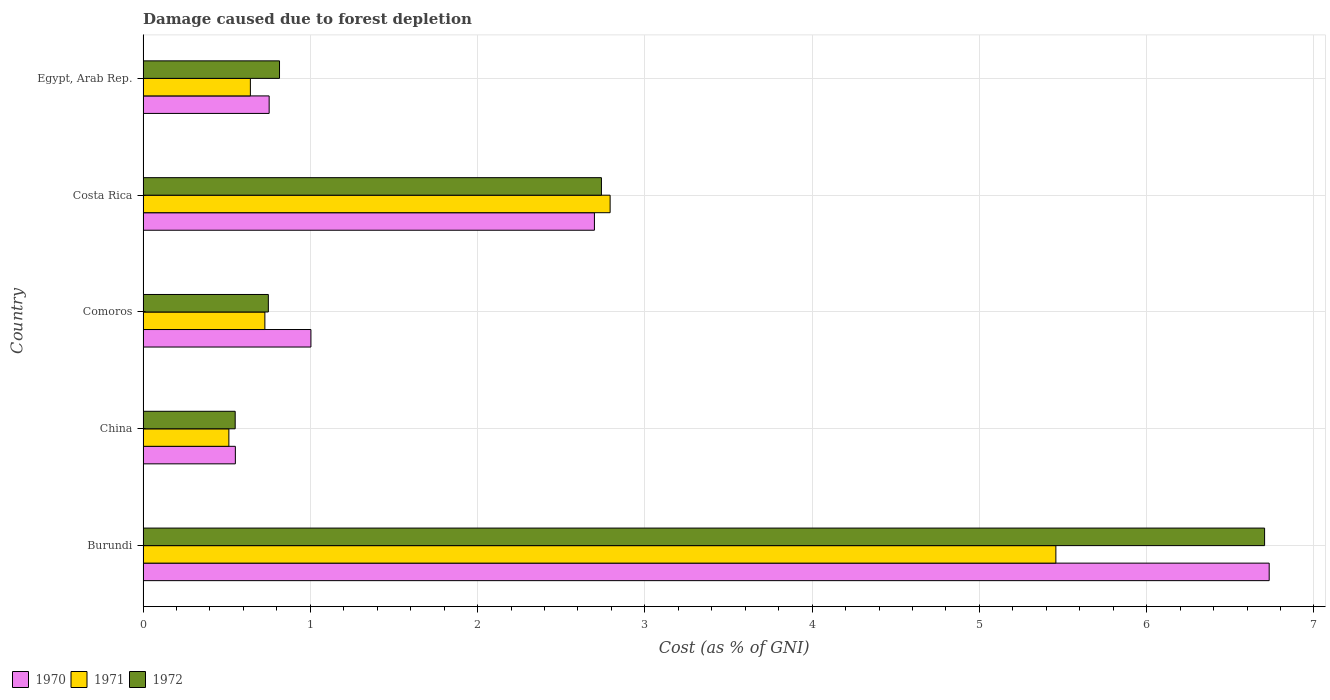Are the number of bars on each tick of the Y-axis equal?
Make the answer very short. Yes. How many bars are there on the 1st tick from the top?
Keep it short and to the point. 3. What is the label of the 1st group of bars from the top?
Give a very brief answer. Egypt, Arab Rep. In how many cases, is the number of bars for a given country not equal to the number of legend labels?
Give a very brief answer. 0. What is the cost of damage caused due to forest depletion in 1970 in Burundi?
Ensure brevity in your answer.  6.73. Across all countries, what is the maximum cost of damage caused due to forest depletion in 1971?
Ensure brevity in your answer.  5.46. Across all countries, what is the minimum cost of damage caused due to forest depletion in 1972?
Provide a succinct answer. 0.55. In which country was the cost of damage caused due to forest depletion in 1972 maximum?
Give a very brief answer. Burundi. What is the total cost of damage caused due to forest depletion in 1972 in the graph?
Keep it short and to the point. 11.56. What is the difference between the cost of damage caused due to forest depletion in 1970 in Burundi and that in China?
Your response must be concise. 6.18. What is the difference between the cost of damage caused due to forest depletion in 1971 in Comoros and the cost of damage caused due to forest depletion in 1972 in Costa Rica?
Your answer should be very brief. -2.01. What is the average cost of damage caused due to forest depletion in 1971 per country?
Offer a terse response. 2.03. What is the difference between the cost of damage caused due to forest depletion in 1972 and cost of damage caused due to forest depletion in 1970 in Egypt, Arab Rep.?
Keep it short and to the point. 0.06. What is the ratio of the cost of damage caused due to forest depletion in 1972 in China to that in Costa Rica?
Your answer should be compact. 0.2. Is the cost of damage caused due to forest depletion in 1972 in China less than that in Comoros?
Ensure brevity in your answer.  Yes. Is the difference between the cost of damage caused due to forest depletion in 1972 in Burundi and China greater than the difference between the cost of damage caused due to forest depletion in 1970 in Burundi and China?
Your response must be concise. No. What is the difference between the highest and the second highest cost of damage caused due to forest depletion in 1971?
Provide a succinct answer. 2.66. What is the difference between the highest and the lowest cost of damage caused due to forest depletion in 1970?
Make the answer very short. 6.18. In how many countries, is the cost of damage caused due to forest depletion in 1970 greater than the average cost of damage caused due to forest depletion in 1970 taken over all countries?
Your response must be concise. 2. Is the sum of the cost of damage caused due to forest depletion in 1971 in China and Costa Rica greater than the maximum cost of damage caused due to forest depletion in 1972 across all countries?
Keep it short and to the point. No. Are all the bars in the graph horizontal?
Make the answer very short. Yes. How many countries are there in the graph?
Give a very brief answer. 5. What is the difference between two consecutive major ticks on the X-axis?
Give a very brief answer. 1. Does the graph contain grids?
Your answer should be compact. Yes. How many legend labels are there?
Ensure brevity in your answer.  3. What is the title of the graph?
Provide a succinct answer. Damage caused due to forest depletion. What is the label or title of the X-axis?
Give a very brief answer. Cost (as % of GNI). What is the Cost (as % of GNI) of 1970 in Burundi?
Your answer should be very brief. 6.73. What is the Cost (as % of GNI) in 1971 in Burundi?
Your answer should be compact. 5.46. What is the Cost (as % of GNI) of 1972 in Burundi?
Give a very brief answer. 6.71. What is the Cost (as % of GNI) of 1970 in China?
Keep it short and to the point. 0.55. What is the Cost (as % of GNI) of 1971 in China?
Make the answer very short. 0.51. What is the Cost (as % of GNI) of 1972 in China?
Your answer should be compact. 0.55. What is the Cost (as % of GNI) of 1970 in Comoros?
Offer a terse response. 1. What is the Cost (as % of GNI) of 1971 in Comoros?
Keep it short and to the point. 0.73. What is the Cost (as % of GNI) in 1972 in Comoros?
Offer a terse response. 0.75. What is the Cost (as % of GNI) in 1970 in Costa Rica?
Your answer should be very brief. 2.7. What is the Cost (as % of GNI) in 1971 in Costa Rica?
Offer a terse response. 2.79. What is the Cost (as % of GNI) of 1972 in Costa Rica?
Your response must be concise. 2.74. What is the Cost (as % of GNI) of 1970 in Egypt, Arab Rep.?
Keep it short and to the point. 0.75. What is the Cost (as % of GNI) in 1971 in Egypt, Arab Rep.?
Your response must be concise. 0.64. What is the Cost (as % of GNI) of 1972 in Egypt, Arab Rep.?
Your answer should be compact. 0.82. Across all countries, what is the maximum Cost (as % of GNI) in 1970?
Your answer should be very brief. 6.73. Across all countries, what is the maximum Cost (as % of GNI) in 1971?
Give a very brief answer. 5.46. Across all countries, what is the maximum Cost (as % of GNI) of 1972?
Your answer should be very brief. 6.71. Across all countries, what is the minimum Cost (as % of GNI) of 1970?
Give a very brief answer. 0.55. Across all countries, what is the minimum Cost (as % of GNI) of 1971?
Provide a succinct answer. 0.51. Across all countries, what is the minimum Cost (as % of GNI) of 1972?
Offer a terse response. 0.55. What is the total Cost (as % of GNI) in 1970 in the graph?
Provide a succinct answer. 11.74. What is the total Cost (as % of GNI) of 1971 in the graph?
Ensure brevity in your answer.  10.13. What is the total Cost (as % of GNI) in 1972 in the graph?
Provide a short and direct response. 11.56. What is the difference between the Cost (as % of GNI) of 1970 in Burundi and that in China?
Offer a terse response. 6.18. What is the difference between the Cost (as % of GNI) of 1971 in Burundi and that in China?
Keep it short and to the point. 4.94. What is the difference between the Cost (as % of GNI) in 1972 in Burundi and that in China?
Provide a succinct answer. 6.15. What is the difference between the Cost (as % of GNI) in 1970 in Burundi and that in Comoros?
Provide a short and direct response. 5.73. What is the difference between the Cost (as % of GNI) of 1971 in Burundi and that in Comoros?
Keep it short and to the point. 4.73. What is the difference between the Cost (as % of GNI) in 1972 in Burundi and that in Comoros?
Your answer should be very brief. 5.96. What is the difference between the Cost (as % of GNI) of 1970 in Burundi and that in Costa Rica?
Provide a short and direct response. 4.03. What is the difference between the Cost (as % of GNI) of 1971 in Burundi and that in Costa Rica?
Your response must be concise. 2.66. What is the difference between the Cost (as % of GNI) of 1972 in Burundi and that in Costa Rica?
Keep it short and to the point. 3.96. What is the difference between the Cost (as % of GNI) of 1970 in Burundi and that in Egypt, Arab Rep.?
Make the answer very short. 5.98. What is the difference between the Cost (as % of GNI) of 1971 in Burundi and that in Egypt, Arab Rep.?
Offer a terse response. 4.82. What is the difference between the Cost (as % of GNI) of 1972 in Burundi and that in Egypt, Arab Rep.?
Your answer should be very brief. 5.89. What is the difference between the Cost (as % of GNI) in 1970 in China and that in Comoros?
Provide a short and direct response. -0.45. What is the difference between the Cost (as % of GNI) in 1971 in China and that in Comoros?
Ensure brevity in your answer.  -0.22. What is the difference between the Cost (as % of GNI) of 1972 in China and that in Comoros?
Provide a short and direct response. -0.2. What is the difference between the Cost (as % of GNI) in 1970 in China and that in Costa Rica?
Your answer should be very brief. -2.15. What is the difference between the Cost (as % of GNI) in 1971 in China and that in Costa Rica?
Provide a succinct answer. -2.28. What is the difference between the Cost (as % of GNI) in 1972 in China and that in Costa Rica?
Your answer should be compact. -2.19. What is the difference between the Cost (as % of GNI) of 1970 in China and that in Egypt, Arab Rep.?
Give a very brief answer. -0.2. What is the difference between the Cost (as % of GNI) in 1971 in China and that in Egypt, Arab Rep.?
Give a very brief answer. -0.13. What is the difference between the Cost (as % of GNI) of 1972 in China and that in Egypt, Arab Rep.?
Your answer should be compact. -0.27. What is the difference between the Cost (as % of GNI) of 1970 in Comoros and that in Costa Rica?
Offer a terse response. -1.7. What is the difference between the Cost (as % of GNI) in 1971 in Comoros and that in Costa Rica?
Provide a short and direct response. -2.06. What is the difference between the Cost (as % of GNI) of 1972 in Comoros and that in Costa Rica?
Provide a succinct answer. -1.99. What is the difference between the Cost (as % of GNI) of 1970 in Comoros and that in Egypt, Arab Rep.?
Your response must be concise. 0.25. What is the difference between the Cost (as % of GNI) in 1971 in Comoros and that in Egypt, Arab Rep.?
Your answer should be very brief. 0.09. What is the difference between the Cost (as % of GNI) in 1972 in Comoros and that in Egypt, Arab Rep.?
Make the answer very short. -0.07. What is the difference between the Cost (as % of GNI) of 1970 in Costa Rica and that in Egypt, Arab Rep.?
Offer a terse response. 1.94. What is the difference between the Cost (as % of GNI) in 1971 in Costa Rica and that in Egypt, Arab Rep.?
Give a very brief answer. 2.15. What is the difference between the Cost (as % of GNI) in 1972 in Costa Rica and that in Egypt, Arab Rep.?
Offer a very short reply. 1.92. What is the difference between the Cost (as % of GNI) in 1970 in Burundi and the Cost (as % of GNI) in 1971 in China?
Keep it short and to the point. 6.22. What is the difference between the Cost (as % of GNI) in 1970 in Burundi and the Cost (as % of GNI) in 1972 in China?
Make the answer very short. 6.18. What is the difference between the Cost (as % of GNI) of 1971 in Burundi and the Cost (as % of GNI) of 1972 in China?
Your answer should be very brief. 4.91. What is the difference between the Cost (as % of GNI) in 1970 in Burundi and the Cost (as % of GNI) in 1971 in Comoros?
Ensure brevity in your answer.  6. What is the difference between the Cost (as % of GNI) in 1970 in Burundi and the Cost (as % of GNI) in 1972 in Comoros?
Keep it short and to the point. 5.98. What is the difference between the Cost (as % of GNI) of 1971 in Burundi and the Cost (as % of GNI) of 1972 in Comoros?
Provide a succinct answer. 4.71. What is the difference between the Cost (as % of GNI) of 1970 in Burundi and the Cost (as % of GNI) of 1971 in Costa Rica?
Your answer should be compact. 3.94. What is the difference between the Cost (as % of GNI) in 1970 in Burundi and the Cost (as % of GNI) in 1972 in Costa Rica?
Provide a succinct answer. 3.99. What is the difference between the Cost (as % of GNI) in 1971 in Burundi and the Cost (as % of GNI) in 1972 in Costa Rica?
Keep it short and to the point. 2.72. What is the difference between the Cost (as % of GNI) in 1970 in Burundi and the Cost (as % of GNI) in 1971 in Egypt, Arab Rep.?
Your response must be concise. 6.09. What is the difference between the Cost (as % of GNI) in 1970 in Burundi and the Cost (as % of GNI) in 1972 in Egypt, Arab Rep.?
Offer a very short reply. 5.92. What is the difference between the Cost (as % of GNI) in 1971 in Burundi and the Cost (as % of GNI) in 1972 in Egypt, Arab Rep.?
Your answer should be very brief. 4.64. What is the difference between the Cost (as % of GNI) in 1970 in China and the Cost (as % of GNI) in 1971 in Comoros?
Give a very brief answer. -0.18. What is the difference between the Cost (as % of GNI) in 1970 in China and the Cost (as % of GNI) in 1972 in Comoros?
Ensure brevity in your answer.  -0.2. What is the difference between the Cost (as % of GNI) of 1971 in China and the Cost (as % of GNI) of 1972 in Comoros?
Keep it short and to the point. -0.24. What is the difference between the Cost (as % of GNI) in 1970 in China and the Cost (as % of GNI) in 1971 in Costa Rica?
Offer a very short reply. -2.24. What is the difference between the Cost (as % of GNI) of 1970 in China and the Cost (as % of GNI) of 1972 in Costa Rica?
Provide a succinct answer. -2.19. What is the difference between the Cost (as % of GNI) in 1971 in China and the Cost (as % of GNI) in 1972 in Costa Rica?
Provide a succinct answer. -2.23. What is the difference between the Cost (as % of GNI) of 1970 in China and the Cost (as % of GNI) of 1971 in Egypt, Arab Rep.?
Provide a short and direct response. -0.09. What is the difference between the Cost (as % of GNI) of 1970 in China and the Cost (as % of GNI) of 1972 in Egypt, Arab Rep.?
Give a very brief answer. -0.26. What is the difference between the Cost (as % of GNI) in 1971 in China and the Cost (as % of GNI) in 1972 in Egypt, Arab Rep.?
Your answer should be compact. -0.3. What is the difference between the Cost (as % of GNI) of 1970 in Comoros and the Cost (as % of GNI) of 1971 in Costa Rica?
Your answer should be very brief. -1.79. What is the difference between the Cost (as % of GNI) in 1970 in Comoros and the Cost (as % of GNI) in 1972 in Costa Rica?
Offer a very short reply. -1.74. What is the difference between the Cost (as % of GNI) in 1971 in Comoros and the Cost (as % of GNI) in 1972 in Costa Rica?
Your answer should be very brief. -2.01. What is the difference between the Cost (as % of GNI) of 1970 in Comoros and the Cost (as % of GNI) of 1971 in Egypt, Arab Rep.?
Your answer should be very brief. 0.36. What is the difference between the Cost (as % of GNI) in 1970 in Comoros and the Cost (as % of GNI) in 1972 in Egypt, Arab Rep.?
Keep it short and to the point. 0.19. What is the difference between the Cost (as % of GNI) of 1971 in Comoros and the Cost (as % of GNI) of 1972 in Egypt, Arab Rep.?
Offer a very short reply. -0.09. What is the difference between the Cost (as % of GNI) of 1970 in Costa Rica and the Cost (as % of GNI) of 1971 in Egypt, Arab Rep.?
Keep it short and to the point. 2.06. What is the difference between the Cost (as % of GNI) in 1970 in Costa Rica and the Cost (as % of GNI) in 1972 in Egypt, Arab Rep.?
Your response must be concise. 1.88. What is the difference between the Cost (as % of GNI) of 1971 in Costa Rica and the Cost (as % of GNI) of 1972 in Egypt, Arab Rep.?
Keep it short and to the point. 1.98. What is the average Cost (as % of GNI) of 1970 per country?
Your answer should be compact. 2.35. What is the average Cost (as % of GNI) of 1971 per country?
Give a very brief answer. 2.03. What is the average Cost (as % of GNI) of 1972 per country?
Provide a short and direct response. 2.31. What is the difference between the Cost (as % of GNI) in 1970 and Cost (as % of GNI) in 1971 in Burundi?
Your response must be concise. 1.28. What is the difference between the Cost (as % of GNI) in 1970 and Cost (as % of GNI) in 1972 in Burundi?
Give a very brief answer. 0.03. What is the difference between the Cost (as % of GNI) in 1971 and Cost (as % of GNI) in 1972 in Burundi?
Keep it short and to the point. -1.25. What is the difference between the Cost (as % of GNI) of 1970 and Cost (as % of GNI) of 1971 in China?
Offer a terse response. 0.04. What is the difference between the Cost (as % of GNI) in 1971 and Cost (as % of GNI) in 1972 in China?
Make the answer very short. -0.04. What is the difference between the Cost (as % of GNI) of 1970 and Cost (as % of GNI) of 1971 in Comoros?
Offer a very short reply. 0.28. What is the difference between the Cost (as % of GNI) in 1970 and Cost (as % of GNI) in 1972 in Comoros?
Ensure brevity in your answer.  0.25. What is the difference between the Cost (as % of GNI) of 1971 and Cost (as % of GNI) of 1972 in Comoros?
Provide a short and direct response. -0.02. What is the difference between the Cost (as % of GNI) in 1970 and Cost (as % of GNI) in 1971 in Costa Rica?
Provide a succinct answer. -0.09. What is the difference between the Cost (as % of GNI) of 1970 and Cost (as % of GNI) of 1972 in Costa Rica?
Keep it short and to the point. -0.04. What is the difference between the Cost (as % of GNI) of 1971 and Cost (as % of GNI) of 1972 in Costa Rica?
Offer a very short reply. 0.05. What is the difference between the Cost (as % of GNI) of 1970 and Cost (as % of GNI) of 1971 in Egypt, Arab Rep.?
Ensure brevity in your answer.  0.11. What is the difference between the Cost (as % of GNI) of 1970 and Cost (as % of GNI) of 1972 in Egypt, Arab Rep.?
Your answer should be very brief. -0.06. What is the difference between the Cost (as % of GNI) in 1971 and Cost (as % of GNI) in 1972 in Egypt, Arab Rep.?
Give a very brief answer. -0.17. What is the ratio of the Cost (as % of GNI) in 1970 in Burundi to that in China?
Provide a succinct answer. 12.2. What is the ratio of the Cost (as % of GNI) of 1971 in Burundi to that in China?
Offer a very short reply. 10.64. What is the ratio of the Cost (as % of GNI) of 1972 in Burundi to that in China?
Your answer should be compact. 12.17. What is the ratio of the Cost (as % of GNI) in 1970 in Burundi to that in Comoros?
Provide a succinct answer. 6.71. What is the ratio of the Cost (as % of GNI) of 1971 in Burundi to that in Comoros?
Provide a succinct answer. 7.49. What is the ratio of the Cost (as % of GNI) in 1972 in Burundi to that in Comoros?
Give a very brief answer. 8.95. What is the ratio of the Cost (as % of GNI) of 1970 in Burundi to that in Costa Rica?
Offer a terse response. 2.49. What is the ratio of the Cost (as % of GNI) of 1971 in Burundi to that in Costa Rica?
Offer a terse response. 1.95. What is the ratio of the Cost (as % of GNI) in 1972 in Burundi to that in Costa Rica?
Provide a succinct answer. 2.45. What is the ratio of the Cost (as % of GNI) of 1970 in Burundi to that in Egypt, Arab Rep.?
Provide a short and direct response. 8.93. What is the ratio of the Cost (as % of GNI) in 1971 in Burundi to that in Egypt, Arab Rep.?
Give a very brief answer. 8.51. What is the ratio of the Cost (as % of GNI) in 1972 in Burundi to that in Egypt, Arab Rep.?
Provide a short and direct response. 8.22. What is the ratio of the Cost (as % of GNI) of 1970 in China to that in Comoros?
Your response must be concise. 0.55. What is the ratio of the Cost (as % of GNI) of 1971 in China to that in Comoros?
Ensure brevity in your answer.  0.7. What is the ratio of the Cost (as % of GNI) in 1972 in China to that in Comoros?
Offer a very short reply. 0.74. What is the ratio of the Cost (as % of GNI) of 1970 in China to that in Costa Rica?
Keep it short and to the point. 0.2. What is the ratio of the Cost (as % of GNI) of 1971 in China to that in Costa Rica?
Provide a succinct answer. 0.18. What is the ratio of the Cost (as % of GNI) of 1972 in China to that in Costa Rica?
Provide a short and direct response. 0.2. What is the ratio of the Cost (as % of GNI) in 1970 in China to that in Egypt, Arab Rep.?
Give a very brief answer. 0.73. What is the ratio of the Cost (as % of GNI) of 1971 in China to that in Egypt, Arab Rep.?
Ensure brevity in your answer.  0.8. What is the ratio of the Cost (as % of GNI) of 1972 in China to that in Egypt, Arab Rep.?
Your answer should be compact. 0.68. What is the ratio of the Cost (as % of GNI) in 1970 in Comoros to that in Costa Rica?
Provide a succinct answer. 0.37. What is the ratio of the Cost (as % of GNI) in 1971 in Comoros to that in Costa Rica?
Offer a very short reply. 0.26. What is the ratio of the Cost (as % of GNI) in 1972 in Comoros to that in Costa Rica?
Your answer should be very brief. 0.27. What is the ratio of the Cost (as % of GNI) in 1970 in Comoros to that in Egypt, Arab Rep.?
Keep it short and to the point. 1.33. What is the ratio of the Cost (as % of GNI) in 1971 in Comoros to that in Egypt, Arab Rep.?
Offer a terse response. 1.14. What is the ratio of the Cost (as % of GNI) in 1972 in Comoros to that in Egypt, Arab Rep.?
Your answer should be very brief. 0.92. What is the ratio of the Cost (as % of GNI) of 1970 in Costa Rica to that in Egypt, Arab Rep.?
Make the answer very short. 3.58. What is the ratio of the Cost (as % of GNI) in 1971 in Costa Rica to that in Egypt, Arab Rep.?
Provide a succinct answer. 4.35. What is the ratio of the Cost (as % of GNI) of 1972 in Costa Rica to that in Egypt, Arab Rep.?
Ensure brevity in your answer.  3.36. What is the difference between the highest and the second highest Cost (as % of GNI) of 1970?
Provide a short and direct response. 4.03. What is the difference between the highest and the second highest Cost (as % of GNI) of 1971?
Your answer should be compact. 2.66. What is the difference between the highest and the second highest Cost (as % of GNI) of 1972?
Give a very brief answer. 3.96. What is the difference between the highest and the lowest Cost (as % of GNI) in 1970?
Your answer should be compact. 6.18. What is the difference between the highest and the lowest Cost (as % of GNI) in 1971?
Provide a succinct answer. 4.94. What is the difference between the highest and the lowest Cost (as % of GNI) in 1972?
Your answer should be compact. 6.15. 